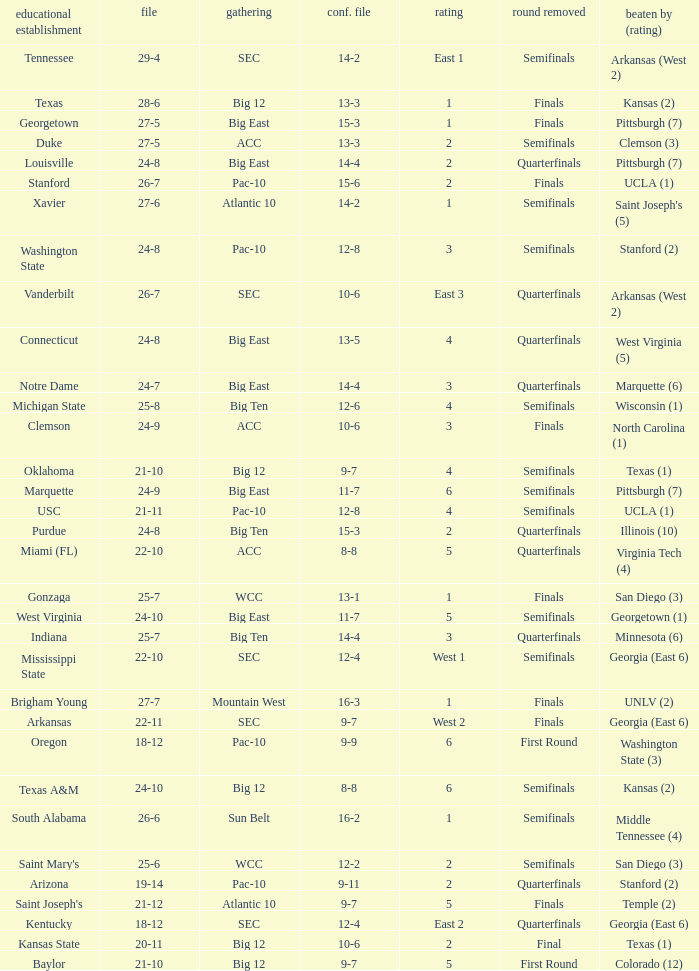Name the round eliminated where conference record is 12-6 Semifinals. 